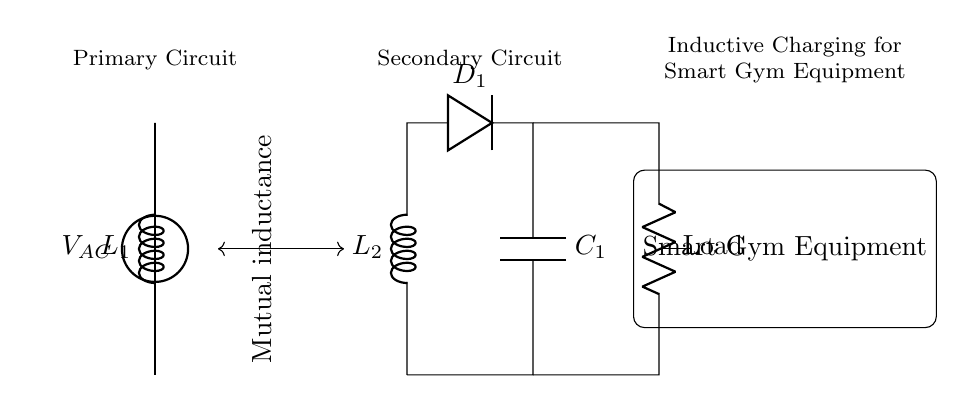What is the voltage source in this circuit? The voltage source is labeled as V_AC, which indicates the alternating current voltage supplied to the primary coil.
Answer: V_AC How many coils are present in this circuit? There are two coils in the circuit: L1 (the primary coil) and L2 (the secondary coil). The primary coil is connected to the voltage source, while the secondary coil has a diode and capacitor connected to it.
Answer: 2 What is the function of D1 in this circuit? D1 is a diode that allows current to flow in only one direction, converting the alternating current from the secondary coil into direct current for the load.
Answer: Rectification What does the mutual inductance represent in this circuit? Mutual inductance represents the coupling between the two coils, L1 and L2. It indicates how the magnetic field generated by the current in L1 induces a voltage in L2, allowing for energy transfer without direct electrical connections.
Answer: Energy transfer What type of load is indicated in the circuit? The load is represented as R, which generally indicates a resistive load. In the context of smart gym equipment, this load could represent various devices or components that require power for operation.
Answer: Resistive 